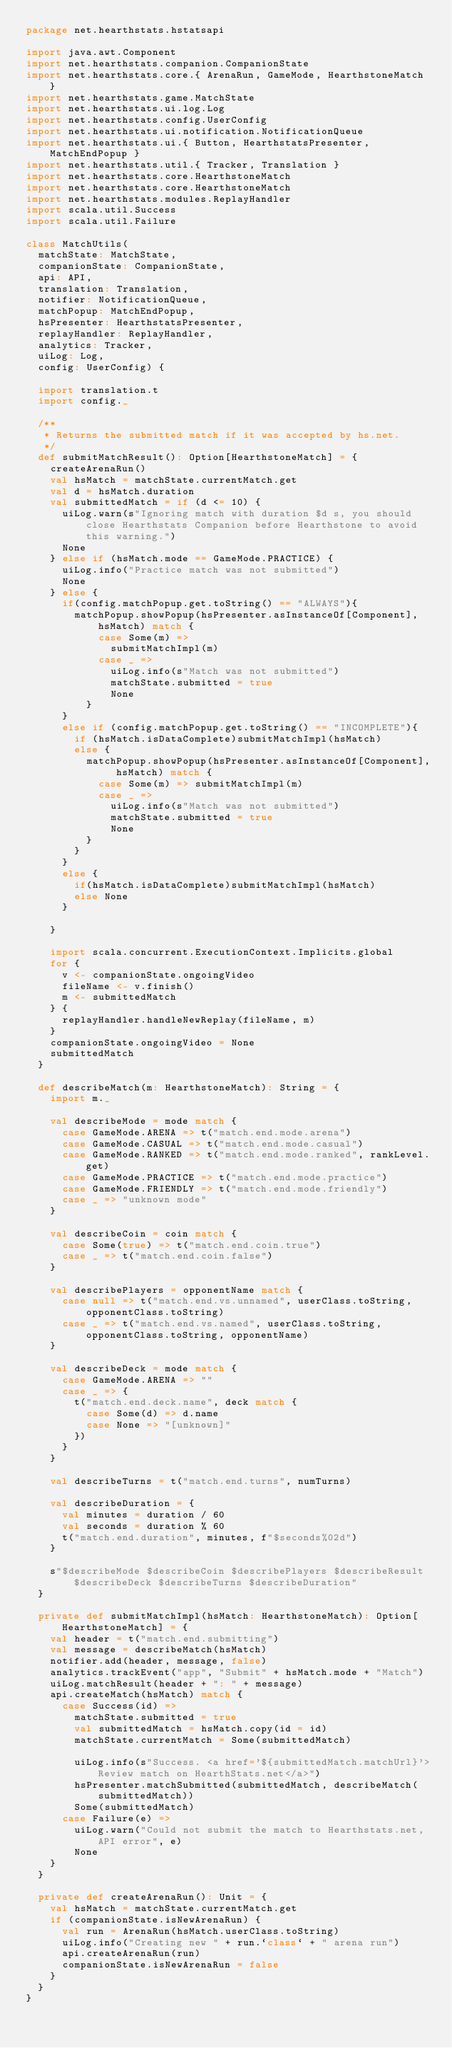Convert code to text. <code><loc_0><loc_0><loc_500><loc_500><_Scala_>package net.hearthstats.hstatsapi

import java.awt.Component
import net.hearthstats.companion.CompanionState
import net.hearthstats.core.{ ArenaRun, GameMode, HearthstoneMatch }
import net.hearthstats.game.MatchState
import net.hearthstats.ui.log.Log
import net.hearthstats.config.UserConfig
import net.hearthstats.ui.notification.NotificationQueue
import net.hearthstats.ui.{ Button, HearthstatsPresenter, MatchEndPopup }
import net.hearthstats.util.{ Tracker, Translation }
import net.hearthstats.core.HearthstoneMatch
import net.hearthstats.core.HearthstoneMatch
import net.hearthstats.modules.ReplayHandler
import scala.util.Success
import scala.util.Failure

class MatchUtils(
  matchState: MatchState,
  companionState: CompanionState,
  api: API,
  translation: Translation,
  notifier: NotificationQueue,
  matchPopup: MatchEndPopup,
  hsPresenter: HearthstatsPresenter,
  replayHandler: ReplayHandler,
  analytics: Tracker,
  uiLog: Log,
  config: UserConfig) {

  import translation.t
  import config._

  /**
   * Returns the submitted match if it was accepted by hs.net.
   */
  def submitMatchResult(): Option[HearthstoneMatch] = {
    createArenaRun()
    val hsMatch = matchState.currentMatch.get
    val d = hsMatch.duration
    val submittedMatch = if (d <= 10) {
      uiLog.warn(s"Ignoring match with duration $d s, you should close Hearthstats Companion before Hearthstone to avoid this warning.")
      None
    } else if (hsMatch.mode == GameMode.PRACTICE) {
      uiLog.info("Practice match was not submitted")
      None
    } else {
      if(config.matchPopup.get.toString() == "ALWAYS"){
        matchPopup.showPopup(hsPresenter.asInstanceOf[Component], hsMatch) match {
            case Some(m) => 
              submitMatchImpl(m)
            case _ =>
              uiLog.info(s"Match was not submitted")
              matchState.submitted = true
              None
          }
      }
      else if (config.matchPopup.get.toString() == "INCOMPLETE"){
        if (hsMatch.isDataComplete)submitMatchImpl(hsMatch) 
        else {
          matchPopup.showPopup(hsPresenter.asInstanceOf[Component], hsMatch) match {
            case Some(m) => submitMatchImpl(m)
            case _ =>
              uiLog.info(s"Match was not submitted")
              matchState.submitted = true
              None
          }
        }
      }
      else {
        if(hsMatch.isDataComplete)submitMatchImpl(hsMatch)
        else None
      }
      
    }

    import scala.concurrent.ExecutionContext.Implicits.global
    for {
      v <- companionState.ongoingVideo
      fileName <- v.finish()
      m <- submittedMatch
    } {
      replayHandler.handleNewReplay(fileName, m)
    }
    companionState.ongoingVideo = None
    submittedMatch
  }

  def describeMatch(m: HearthstoneMatch): String = {
    import m._

    val describeMode = mode match {
      case GameMode.ARENA => t("match.end.mode.arena")
      case GameMode.CASUAL => t("match.end.mode.casual")
      case GameMode.RANKED => t("match.end.mode.ranked", rankLevel.get)
      case GameMode.PRACTICE => t("match.end.mode.practice")
      case GameMode.FRIENDLY => t("match.end.mode.friendly")
      case _ => "unknown mode"
    }

    val describeCoin = coin match {
      case Some(true) => t("match.end.coin.true")
      case _ => t("match.end.coin.false")
    }

    val describePlayers = opponentName match {
      case null => t("match.end.vs.unnamed", userClass.toString, opponentClass.toString)
      case _ => t("match.end.vs.named", userClass.toString, opponentClass.toString, opponentName)
    }

    val describeDeck = mode match {
      case GameMode.ARENA => ""
      case _ => {
        t("match.end.deck.name", deck match {
          case Some(d) => d.name
          case None => "[unknown]"
        })
      }
    }

    val describeTurns = t("match.end.turns", numTurns)

    val describeDuration = {
      val minutes = duration / 60
      val seconds = duration % 60
      t("match.end.duration", minutes, f"$seconds%02d")
    }

    s"$describeMode $describeCoin $describePlayers $describeResult $describeDeck $describeTurns $describeDuration"
  }

  private def submitMatchImpl(hsMatch: HearthstoneMatch): Option[HearthstoneMatch] = {
    val header = t("match.end.submitting")
    val message = describeMatch(hsMatch)
    notifier.add(header, message, false)
    analytics.trackEvent("app", "Submit" + hsMatch.mode + "Match")
    uiLog.matchResult(header + ": " + message)
    api.createMatch(hsMatch) match {
      case Success(id) =>
        matchState.submitted = true
        val submittedMatch = hsMatch.copy(id = id)
        matchState.currentMatch = Some(submittedMatch)

        uiLog.info(s"Success. <a href='${submittedMatch.matchUrl}'>Review match on HearthStats.net</a>")
        hsPresenter.matchSubmitted(submittedMatch, describeMatch(submittedMatch))
        Some(submittedMatch)
      case Failure(e) =>
        uiLog.warn("Could not submit the match to Hearthstats.net, API error", e)
        None
    }
  }

  private def createArenaRun(): Unit = {
    val hsMatch = matchState.currentMatch.get
    if (companionState.isNewArenaRun) {
      val run = ArenaRun(hsMatch.userClass.toString)
      uiLog.info("Creating new " + run.`class` + " arena run")
      api.createArenaRun(run)
      companionState.isNewArenaRun = false
    }
  }
}</code> 